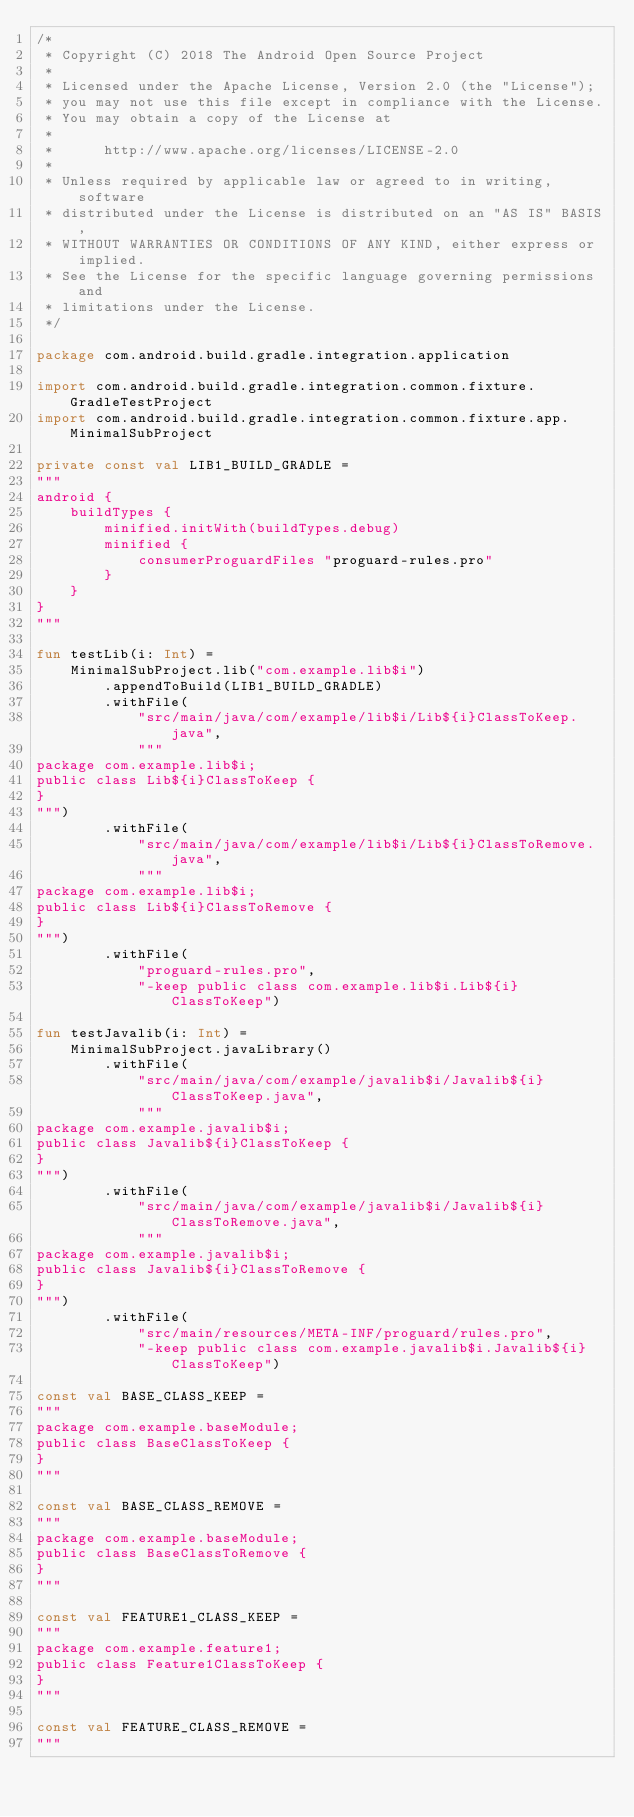Convert code to text. <code><loc_0><loc_0><loc_500><loc_500><_Kotlin_>/*
 * Copyright (C) 2018 The Android Open Source Project
 *
 * Licensed under the Apache License, Version 2.0 (the "License");
 * you may not use this file except in compliance with the License.
 * You may obtain a copy of the License at
 *
 *      http://www.apache.org/licenses/LICENSE-2.0
 *
 * Unless required by applicable law or agreed to in writing, software
 * distributed under the License is distributed on an "AS IS" BASIS,
 * WITHOUT WARRANTIES OR CONDITIONS OF ANY KIND, either express or implied.
 * See the License for the specific language governing permissions and
 * limitations under the License.
 */

package com.android.build.gradle.integration.application

import com.android.build.gradle.integration.common.fixture.GradleTestProject
import com.android.build.gradle.integration.common.fixture.app.MinimalSubProject

private const val LIB1_BUILD_GRADLE =
"""
android {
    buildTypes {
        minified.initWith(buildTypes.debug)
        minified {
            consumerProguardFiles "proguard-rules.pro"
        }
    }
}
"""

fun testLib(i: Int) =
    MinimalSubProject.lib("com.example.lib$i")
        .appendToBuild(LIB1_BUILD_GRADLE)
        .withFile(
            "src/main/java/com/example/lib$i/Lib${i}ClassToKeep.java",
            """
package com.example.lib$i;
public class Lib${i}ClassToKeep {
}
""")
        .withFile(
            "src/main/java/com/example/lib$i/Lib${i}ClassToRemove.java",
            """
package com.example.lib$i;
public class Lib${i}ClassToRemove {
}
""")
        .withFile(
            "proguard-rules.pro",
            "-keep public class com.example.lib$i.Lib${i}ClassToKeep")

fun testJavalib(i: Int) =
    MinimalSubProject.javaLibrary()
        .withFile(
            "src/main/java/com/example/javalib$i/Javalib${i}ClassToKeep.java",
            """
package com.example.javalib$i;
public class Javalib${i}ClassToKeep {
}
""")
        .withFile(
            "src/main/java/com/example/javalib$i/Javalib${i}ClassToRemove.java",
            """
package com.example.javalib$i;
public class Javalib${i}ClassToRemove {
}
""")
        .withFile(
            "src/main/resources/META-INF/proguard/rules.pro",
            "-keep public class com.example.javalib$i.Javalib${i}ClassToKeep")

const val BASE_CLASS_KEEP =
"""
package com.example.baseModule;
public class BaseClassToKeep {
}
"""

const val BASE_CLASS_REMOVE =
"""
package com.example.baseModule;
public class BaseClassToRemove {
}
"""

const val FEATURE1_CLASS_KEEP =
"""
package com.example.feature1;
public class Feature1ClassToKeep {
}
"""

const val FEATURE_CLASS_REMOVE =
"""</code> 